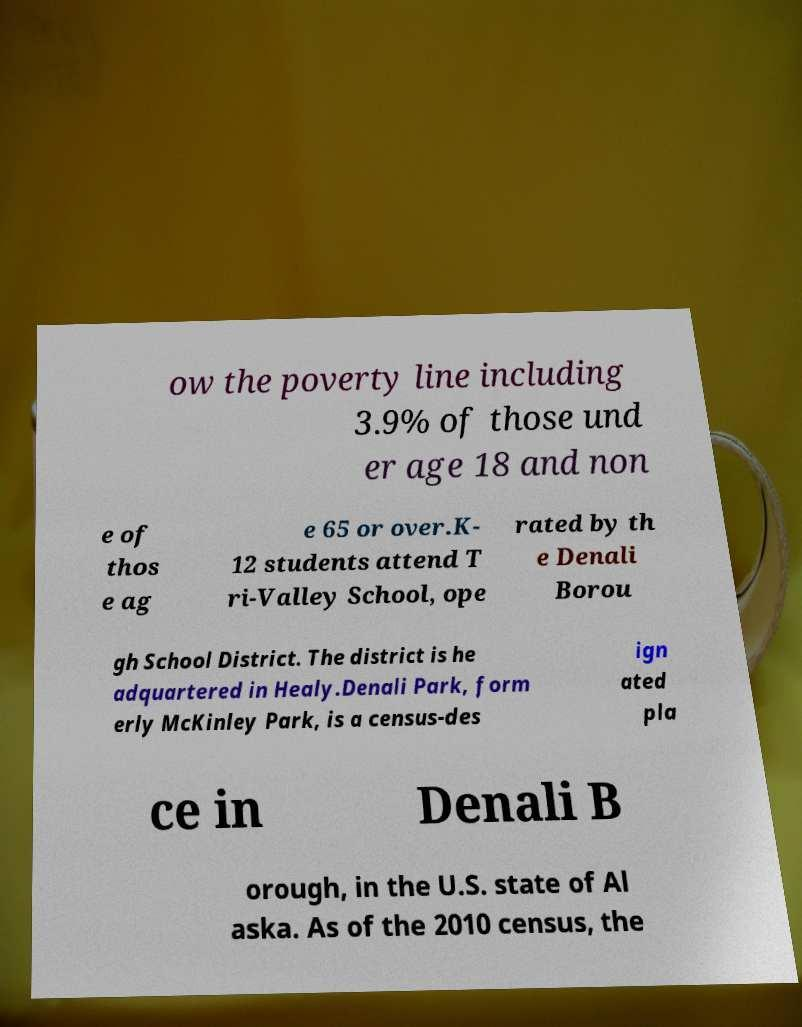Can you accurately transcribe the text from the provided image for me? ow the poverty line including 3.9% of those und er age 18 and non e of thos e ag e 65 or over.K- 12 students attend T ri-Valley School, ope rated by th e Denali Borou gh School District. The district is he adquartered in Healy.Denali Park, form erly McKinley Park, is a census-des ign ated pla ce in Denali B orough, in the U.S. state of Al aska. As of the 2010 census, the 